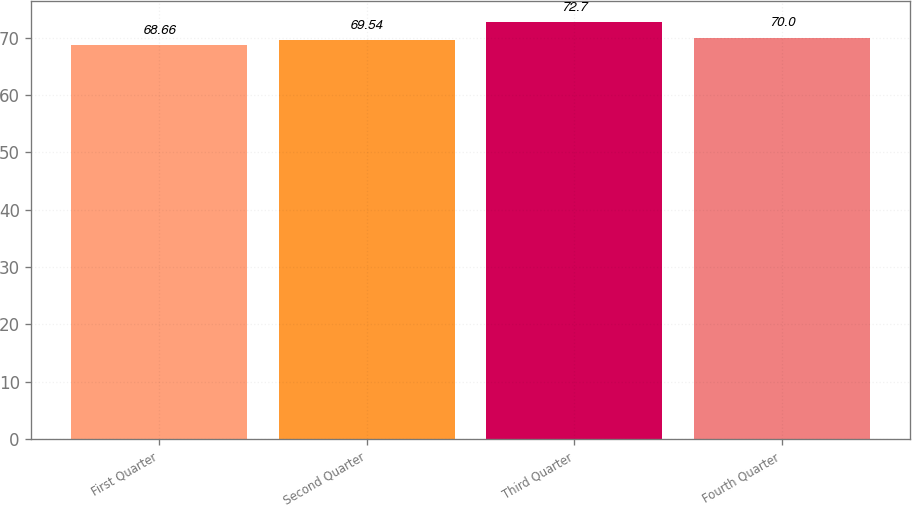Convert chart. <chart><loc_0><loc_0><loc_500><loc_500><bar_chart><fcel>First Quarter<fcel>Second Quarter<fcel>Third Quarter<fcel>Fourth Quarter<nl><fcel>68.66<fcel>69.54<fcel>72.7<fcel>70<nl></chart> 